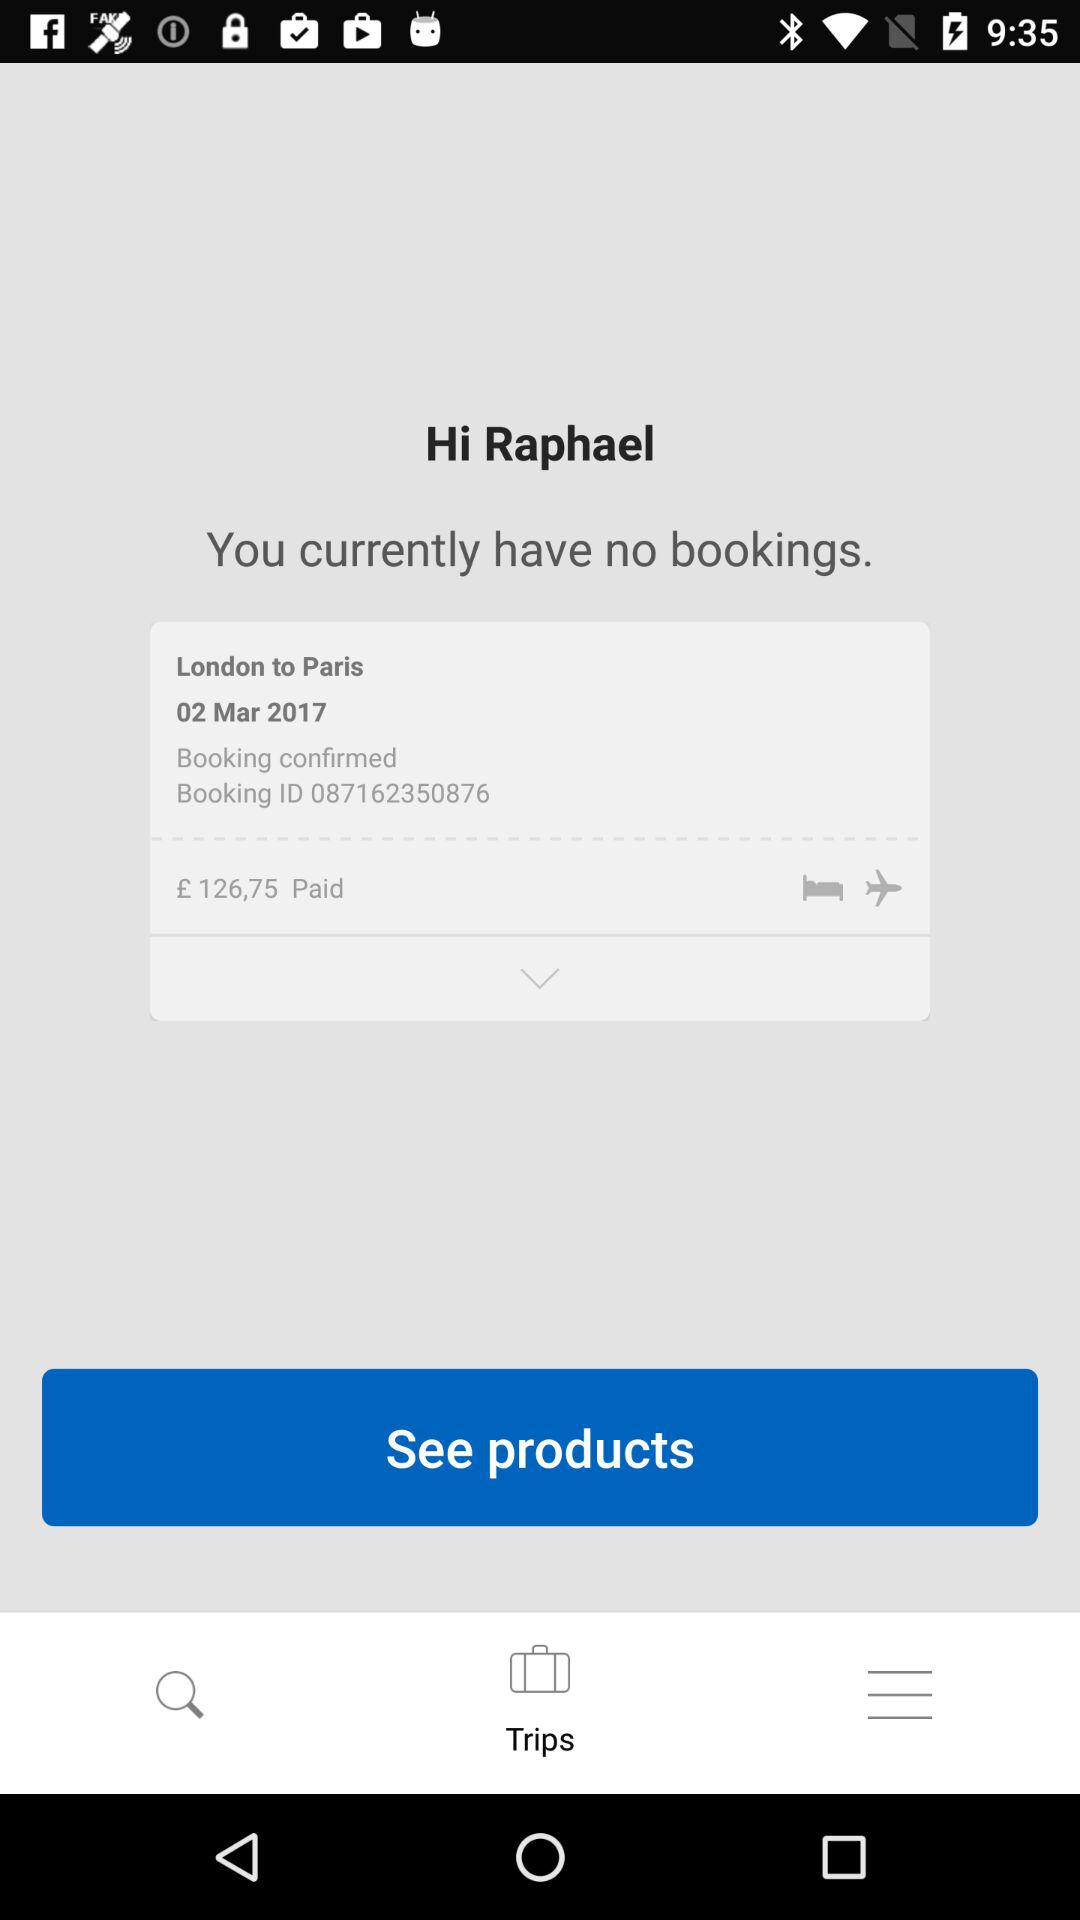What is the user name? The user name is Raphael. 